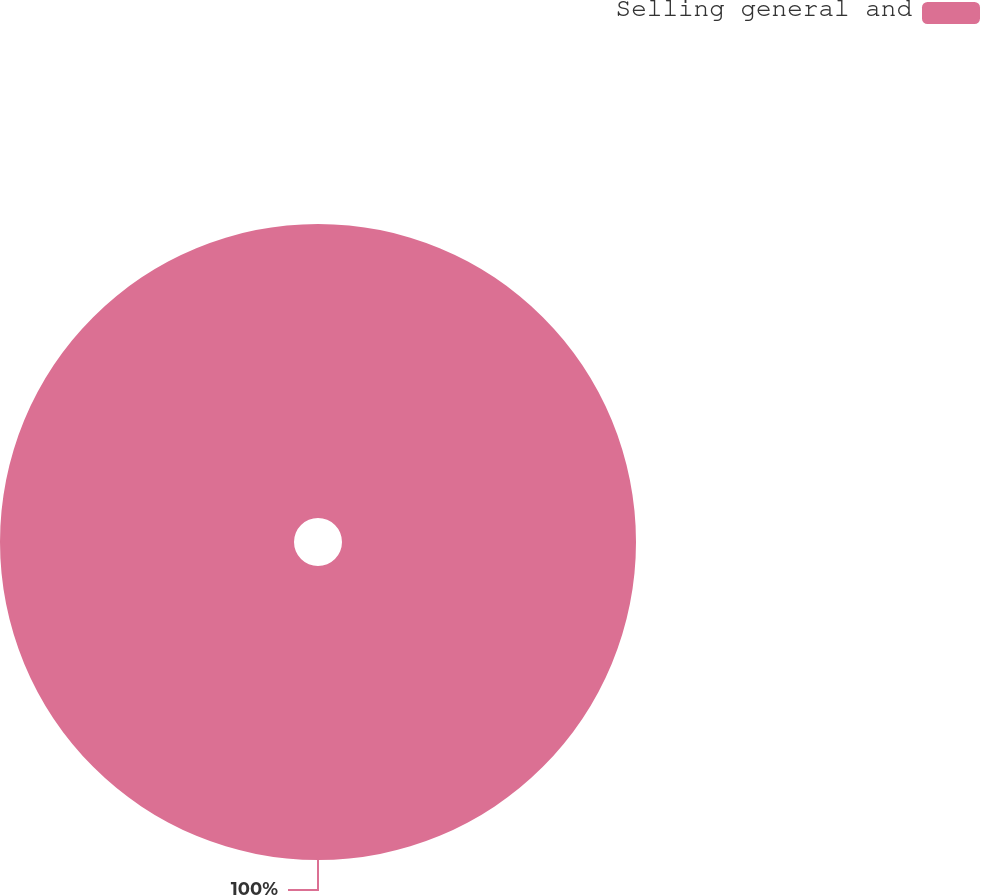Convert chart to OTSL. <chart><loc_0><loc_0><loc_500><loc_500><pie_chart><fcel>Selling general and<nl><fcel>100.0%<nl></chart> 